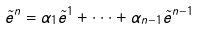Convert formula to latex. <formula><loc_0><loc_0><loc_500><loc_500>\tilde { e } ^ { n } = \alpha _ { 1 } \tilde { e } ^ { 1 } + \cdot \cdot \cdot + \alpha _ { n - 1 } \tilde { e } ^ { n - 1 }</formula> 